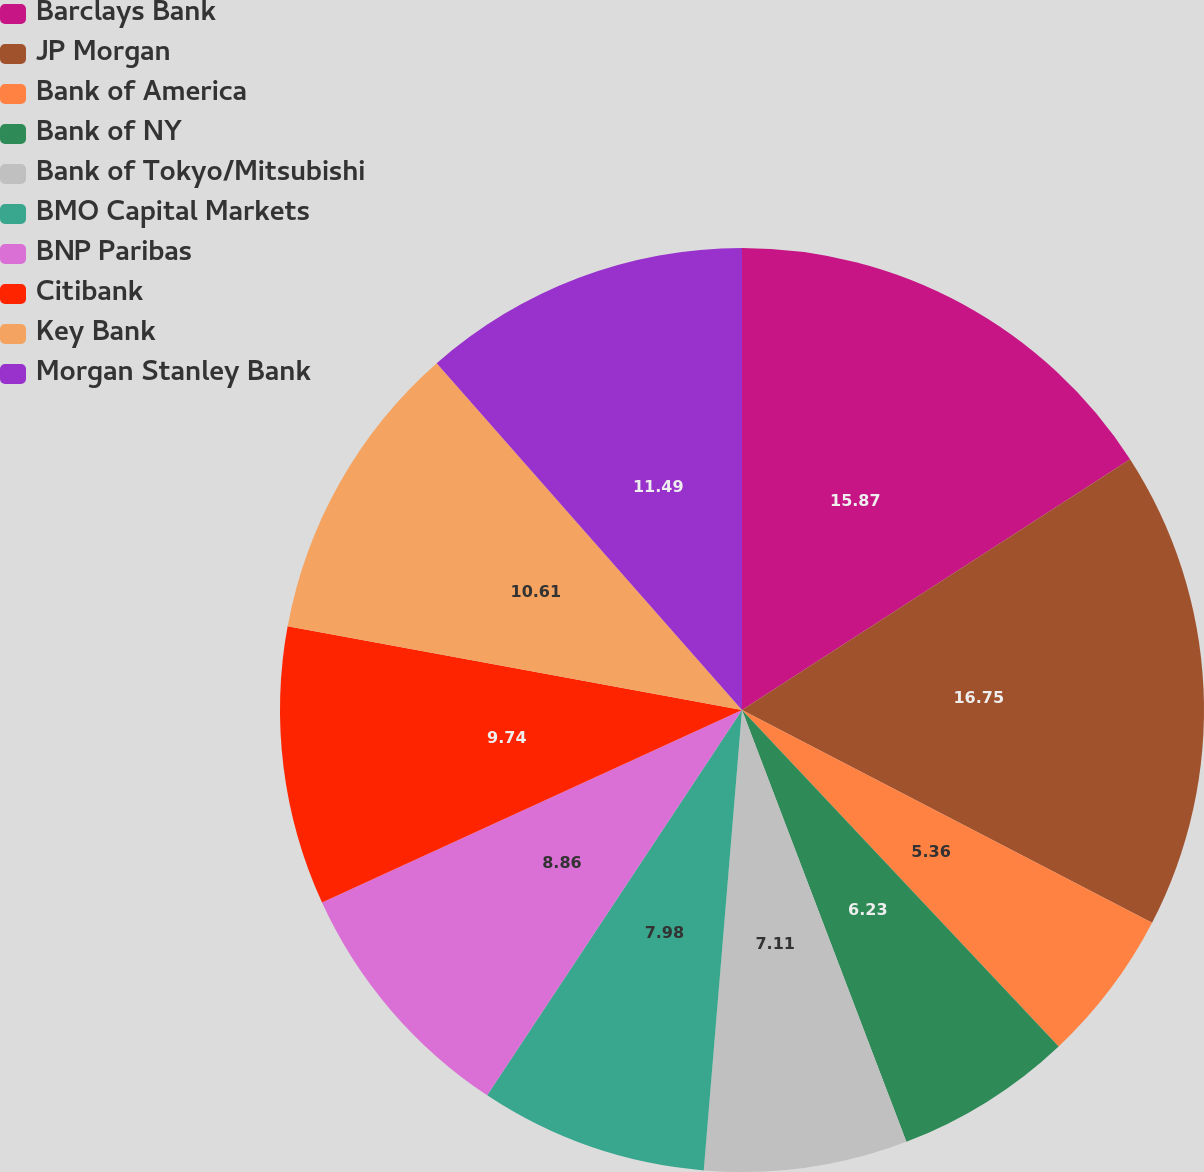Convert chart to OTSL. <chart><loc_0><loc_0><loc_500><loc_500><pie_chart><fcel>Barclays Bank<fcel>JP Morgan<fcel>Bank of America<fcel>Bank of NY<fcel>Bank of Tokyo/Mitsubishi<fcel>BMO Capital Markets<fcel>BNP Paribas<fcel>Citibank<fcel>Key Bank<fcel>Morgan Stanley Bank<nl><fcel>15.87%<fcel>16.75%<fcel>5.36%<fcel>6.23%<fcel>7.11%<fcel>7.98%<fcel>8.86%<fcel>9.74%<fcel>10.61%<fcel>11.49%<nl></chart> 